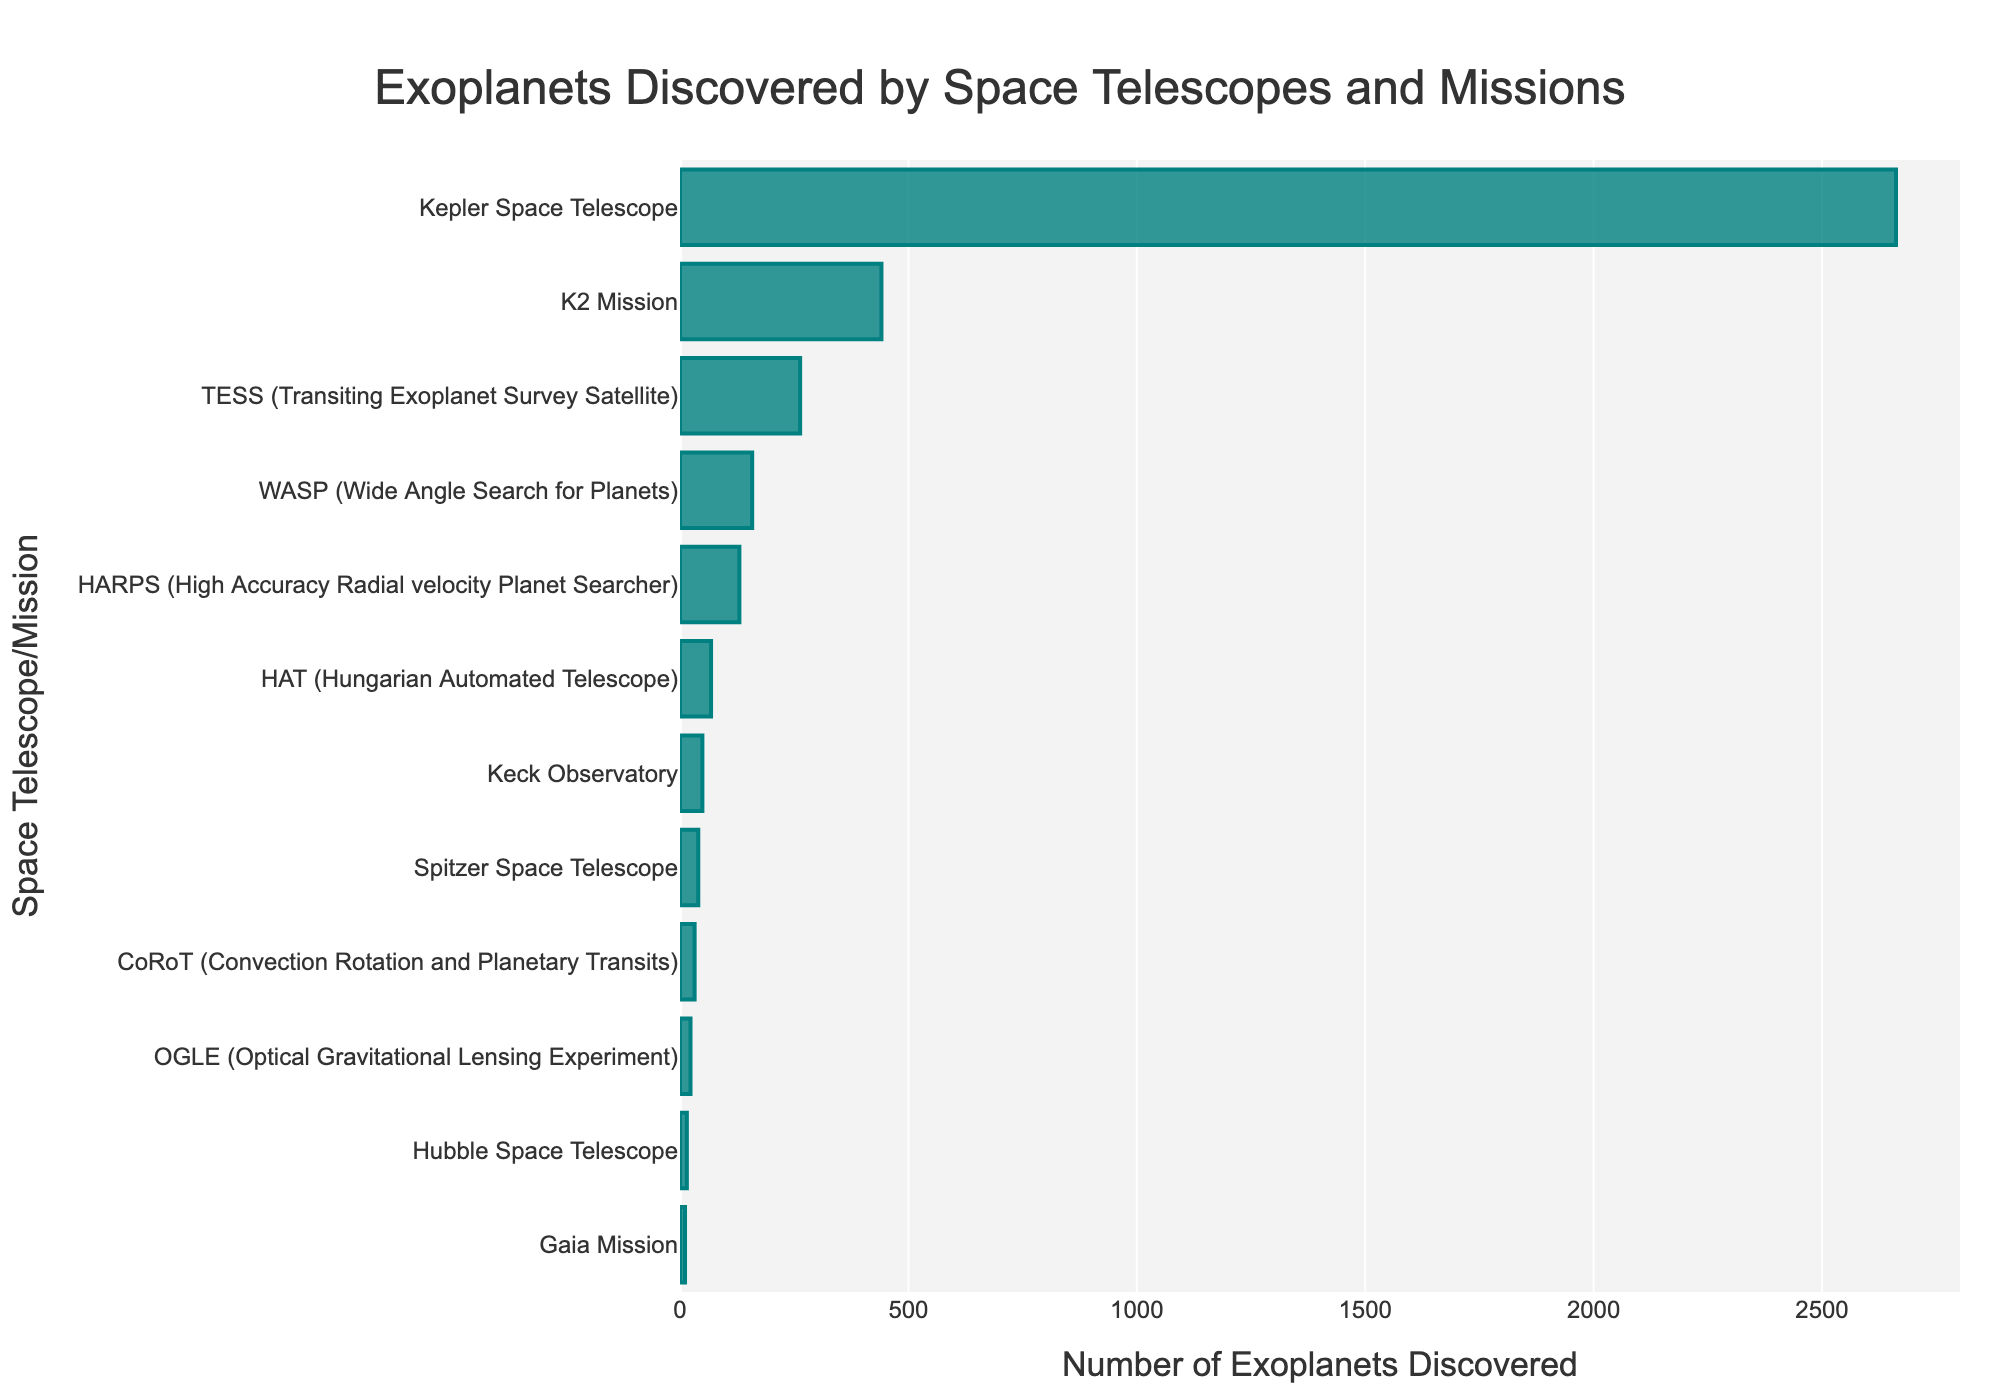Which space telescope discovered the most exoplanets? By examining the lengths of the bars representing the number of exoplanets discovered by each space telescope, the longest bar corresponds to the Kepler Space Telescope.
Answer: Kepler Space Telescope How many more exoplanets did the Kepler Space Telescope discover than the TESS mission? The number of exoplanets discovered by the Kepler Space Telescope is 2662, and by TESS is 263. The difference is 2662 - 263.
Answer: 2399 Which two missions discovered the fewest exoplanets, and how many did they discover? The shortest bars on the chart belong to the Gaia Mission and Hubble Space Telescope with 11 and 15 exoplanets respectively.
Answer: Gaia Mission (11) and Hubble Space Telescope (15) What is the combined total of exoplanets discovered by the HARPS and WASP missions? The number of exoplanets discovered by HARPS is 130, and by WASP is 158. The combined total is 130 + 158.
Answer: 288 Which mission discovered fewer exoplanets: Spitzer Space Telescope or Keck Observatory? By comparing the lengths of the bars, the Keck Observatory discovered fewer exoplanets with 49, while Spitzer discovered 40.
Answer: Spitzer Space Telescope What is the approximate average number of exoplanets discovered by Kepler Space Telescope, K2 Mission, and TESS? Sum the numbers: 2662 (Kepler) + 441 (K2) + 263 (TESS) = 3366. There are 3 missions, so the average is 3366 / 3.
Answer: Approximately 1122 By how much does the number of exoplanets discovered by OGLE exceed that discovered by Gaia Mission? OGLE discovered 23 exoplanets and Gaia Mission discovered 11 exoplanets. The difference is 23 - 11.
Answer: 12 Which mission discovered more exoplanets: CoRoT or HAT? By looking at the lengths of the bars, CoRoT discovered 32 exoplanets, whereas HAT discovered 68.
Answer: HAT What is the difference in the number of exoplanets discovered by the HAT and OGLE missions? HAT discovered 68 exoplanets, and OGLE discovered 23. The difference is 68 - 23.
Answer: 45 